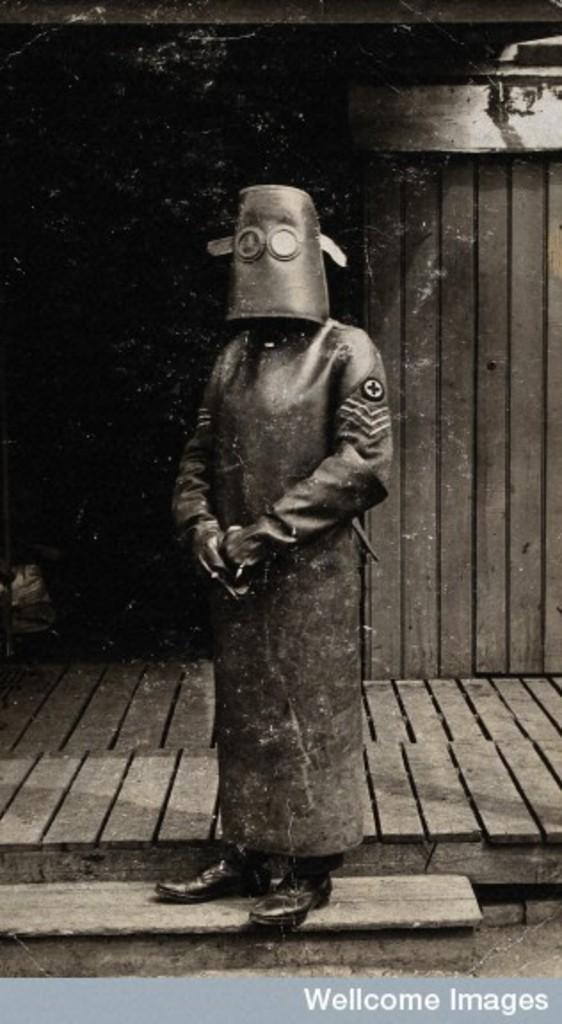In one or two sentences, can you explain what this image depicts? In the image a person is standing and wearing long suit,background is with a wooden wall. 